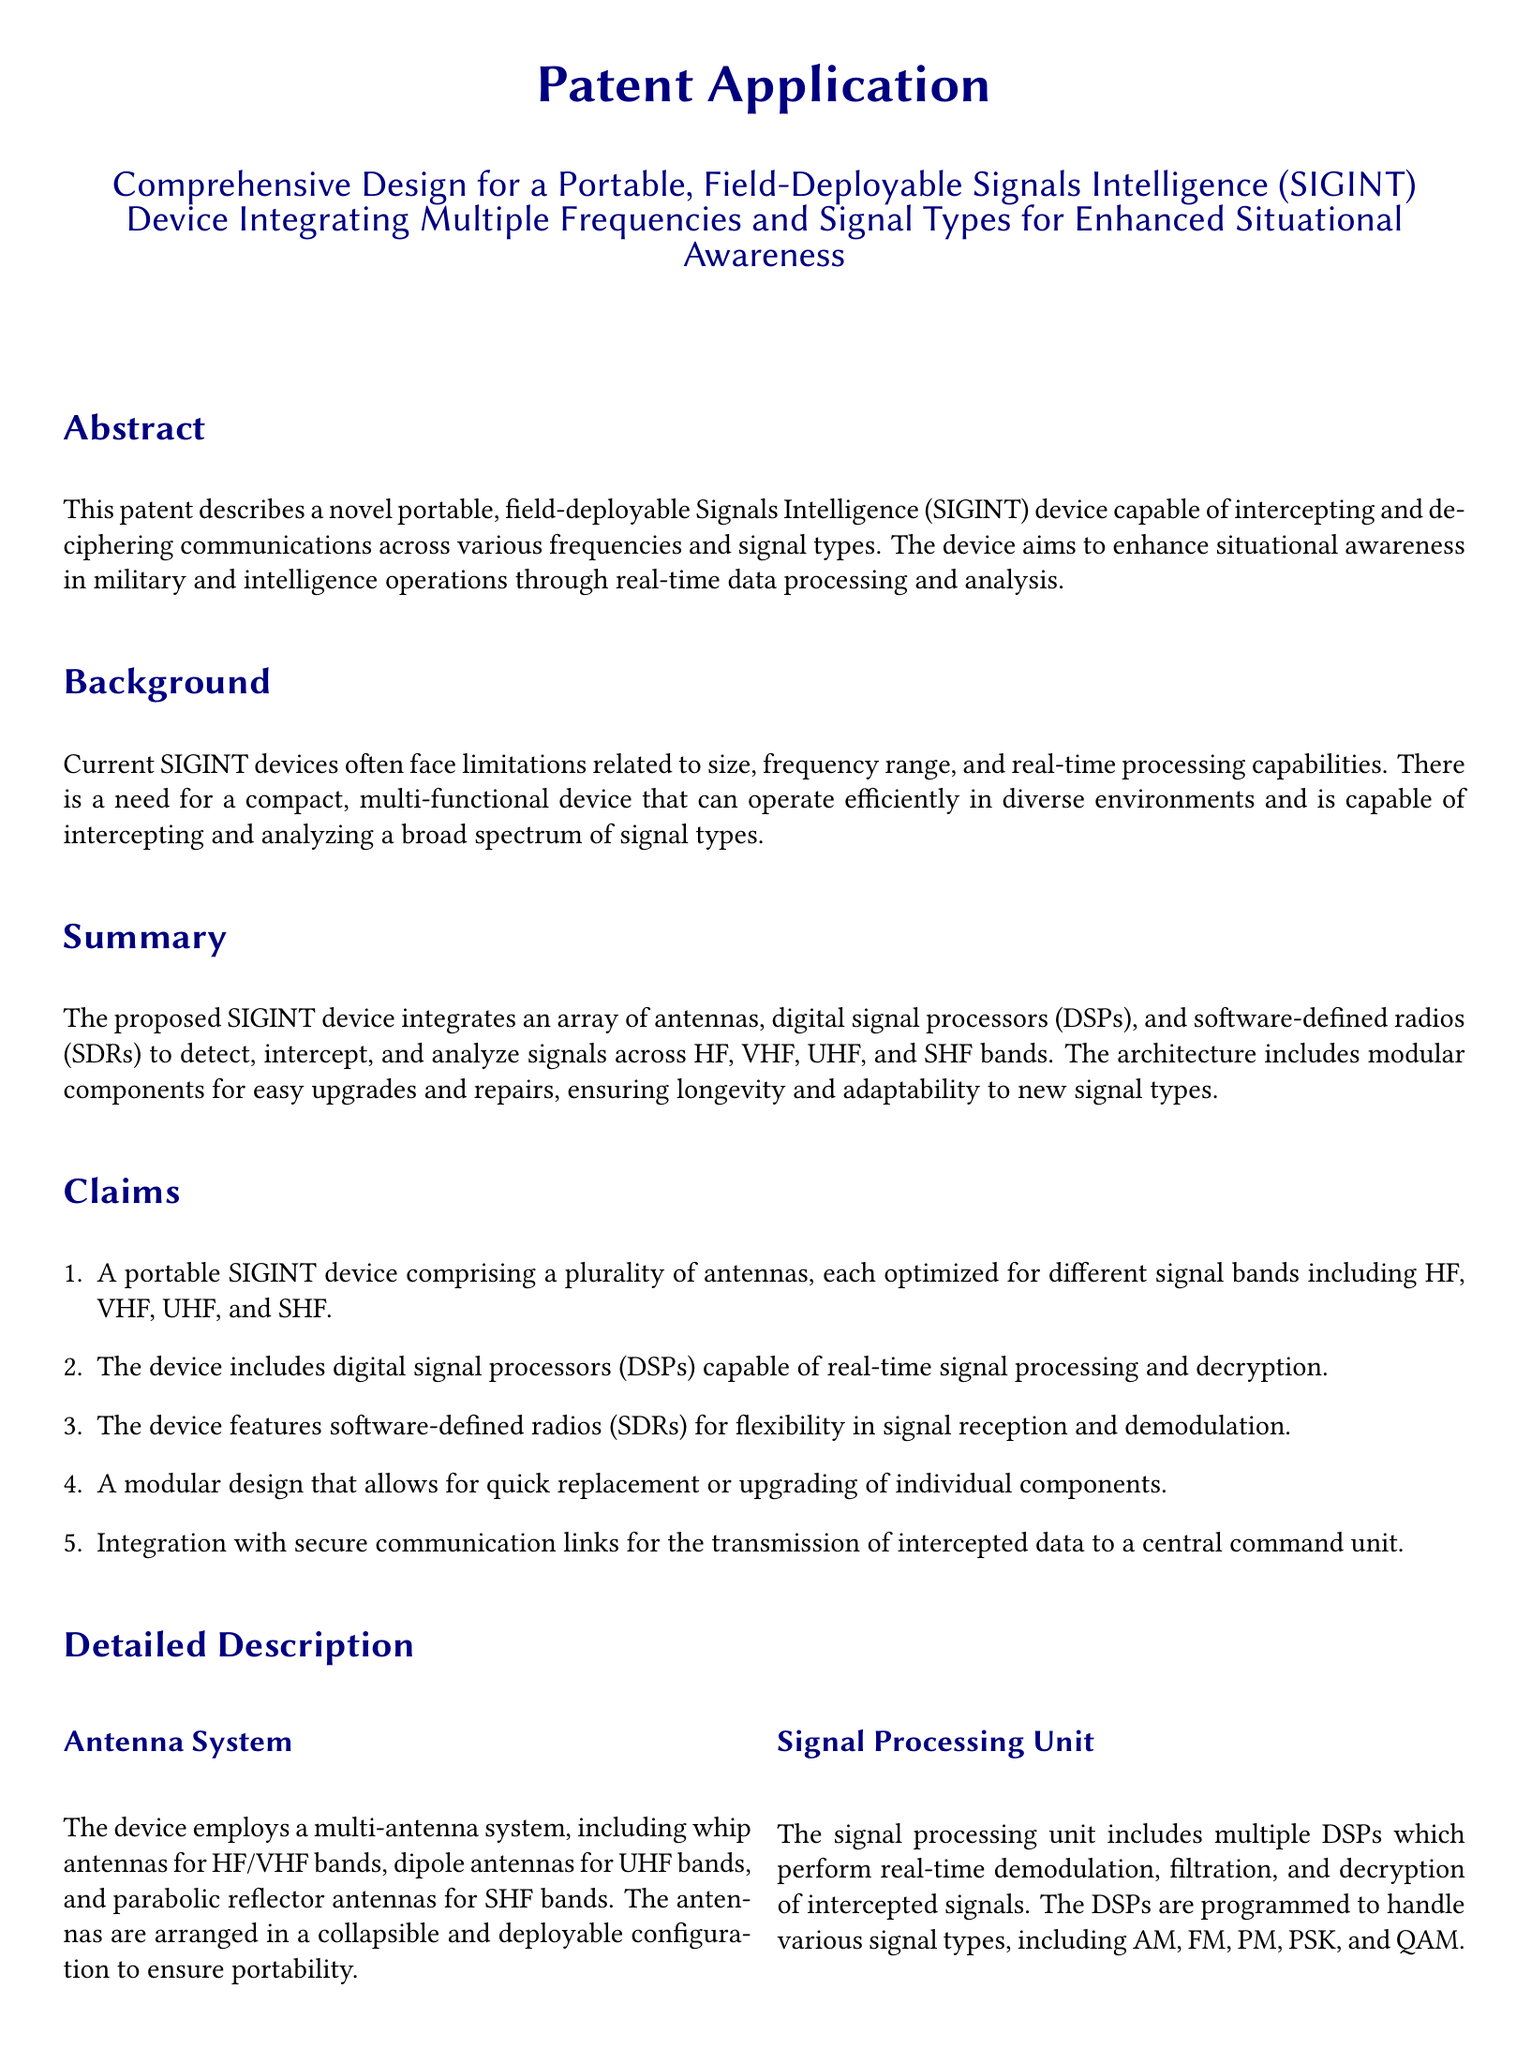What is the focus of the patent application? The patent application focuses on a portable, field-deployable Signals Intelligence (SIGINT) device.
Answer: Portable, field-deployable Signals Intelligence (SIGINT) device How many frequency bands does the device operate on? The device operates across HF, VHF, UHF, and SHF bands, which totals four frequency bands.
Answer: Four bands What component allows the device to dynamically switch frequency bands? The Software Defined Radios (SDRs) enable dynamic switching between different frequency bands.
Answer: Software Defined Radios (SDRs) What is one key feature of the portable SIGINT device's design? The device features a modular design allowing for easy replacement or upgrading of components.
Answer: Modular design For what type of operations is this SIGINT device intended? One intended operation is military intelligence and reconnaissance operations.
Answer: Military intelligence and reconnaissance operations Which secure communication link is mentioned for transmission of intercepted data? The device includes encrypted Wi-Fi as one type of secure communication link.
Answer: Encrypted Wi-Fi What processing capabilities do the digital signal processors (DSPs) provide? The DSPs perform real-time demodulation, filtration, and decryption of signals.
Answer: Real-time demodulation, filtration, and decryption What does the modular design of the device ensure in terms of functionality? The modular design ensures the device remains operational with minimal downtime.
Answer: Minimal downtime 